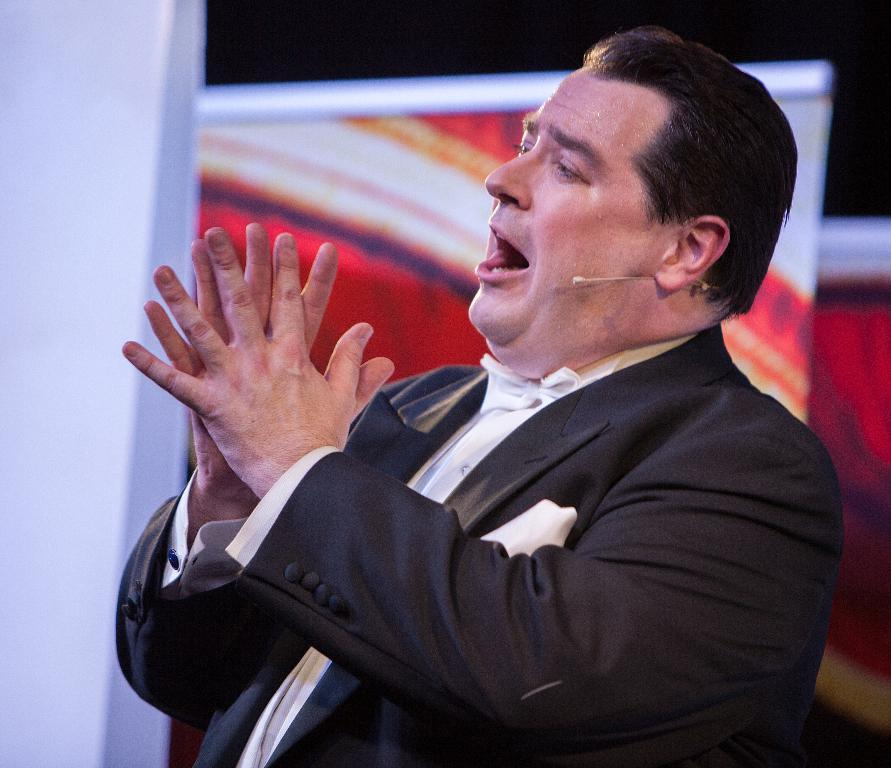Who or what is the main subject in the center of the image? There is a person in the center of the image. What is the person wearing? The person is wearing a suit. What can be seen in the background of the image? There are banners in the background of the image. What type of soup is being served in the image? There is no soup present in the image. What is the person doing with the crate in the image? There is no crate present in the image. 